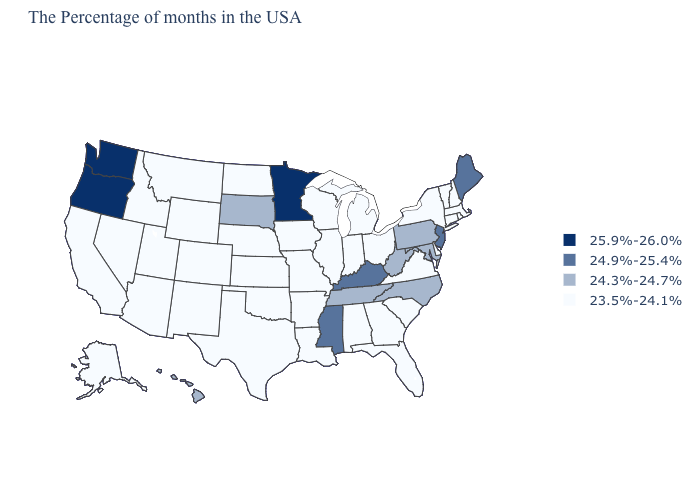Is the legend a continuous bar?
Short answer required. No. Name the states that have a value in the range 24.3%-24.7%?
Short answer required. Maryland, Pennsylvania, North Carolina, West Virginia, Tennessee, South Dakota, Hawaii. What is the value of Vermont?
Answer briefly. 23.5%-24.1%. What is the highest value in the USA?
Quick response, please. 25.9%-26.0%. Among the states that border North Dakota , which have the lowest value?
Be succinct. Montana. Does Washington have a higher value than Tennessee?
Keep it brief. Yes. What is the lowest value in states that border Tennessee?
Write a very short answer. 23.5%-24.1%. Which states have the highest value in the USA?
Give a very brief answer. Minnesota, Washington, Oregon. What is the lowest value in the USA?
Keep it brief. 23.5%-24.1%. Name the states that have a value in the range 25.9%-26.0%?
Be succinct. Minnesota, Washington, Oregon. What is the value of Florida?
Keep it brief. 23.5%-24.1%. What is the lowest value in the Northeast?
Short answer required. 23.5%-24.1%. What is the lowest value in states that border Nebraska?
Keep it brief. 23.5%-24.1%. Does Oregon have the highest value in the USA?
Write a very short answer. Yes. 